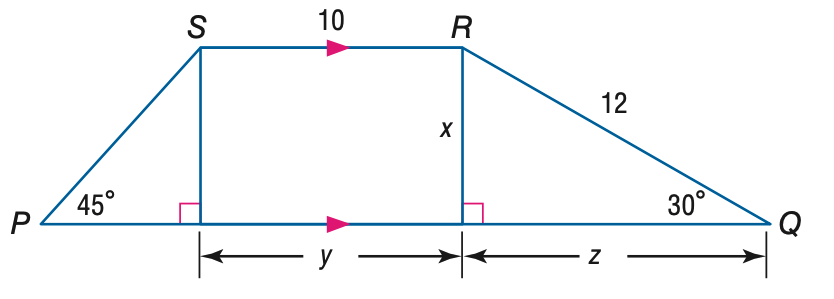Answer the mathemtical geometry problem and directly provide the correct option letter.
Question: Find the perimeter of trapezoid P Q R S.
Choices: A: 38 B: 38 + 6 \sqrt { 2 } C: 38 + 6 \sqrt { 3 } D: 38 + 6 \sqrt { 2 } + 6 \sqrt { 3 } D 